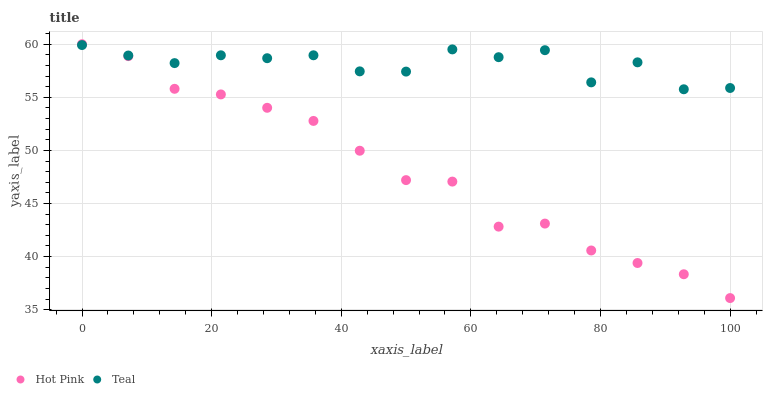Does Hot Pink have the minimum area under the curve?
Answer yes or no. Yes. Does Teal have the maximum area under the curve?
Answer yes or no. Yes. Does Teal have the minimum area under the curve?
Answer yes or no. No. Is Hot Pink the smoothest?
Answer yes or no. Yes. Is Teal the roughest?
Answer yes or no. Yes. Is Teal the smoothest?
Answer yes or no. No. Does Hot Pink have the lowest value?
Answer yes or no. Yes. Does Teal have the lowest value?
Answer yes or no. No. Does Hot Pink have the highest value?
Answer yes or no. Yes. Does Teal have the highest value?
Answer yes or no. No. Does Hot Pink intersect Teal?
Answer yes or no. Yes. Is Hot Pink less than Teal?
Answer yes or no. No. Is Hot Pink greater than Teal?
Answer yes or no. No. 